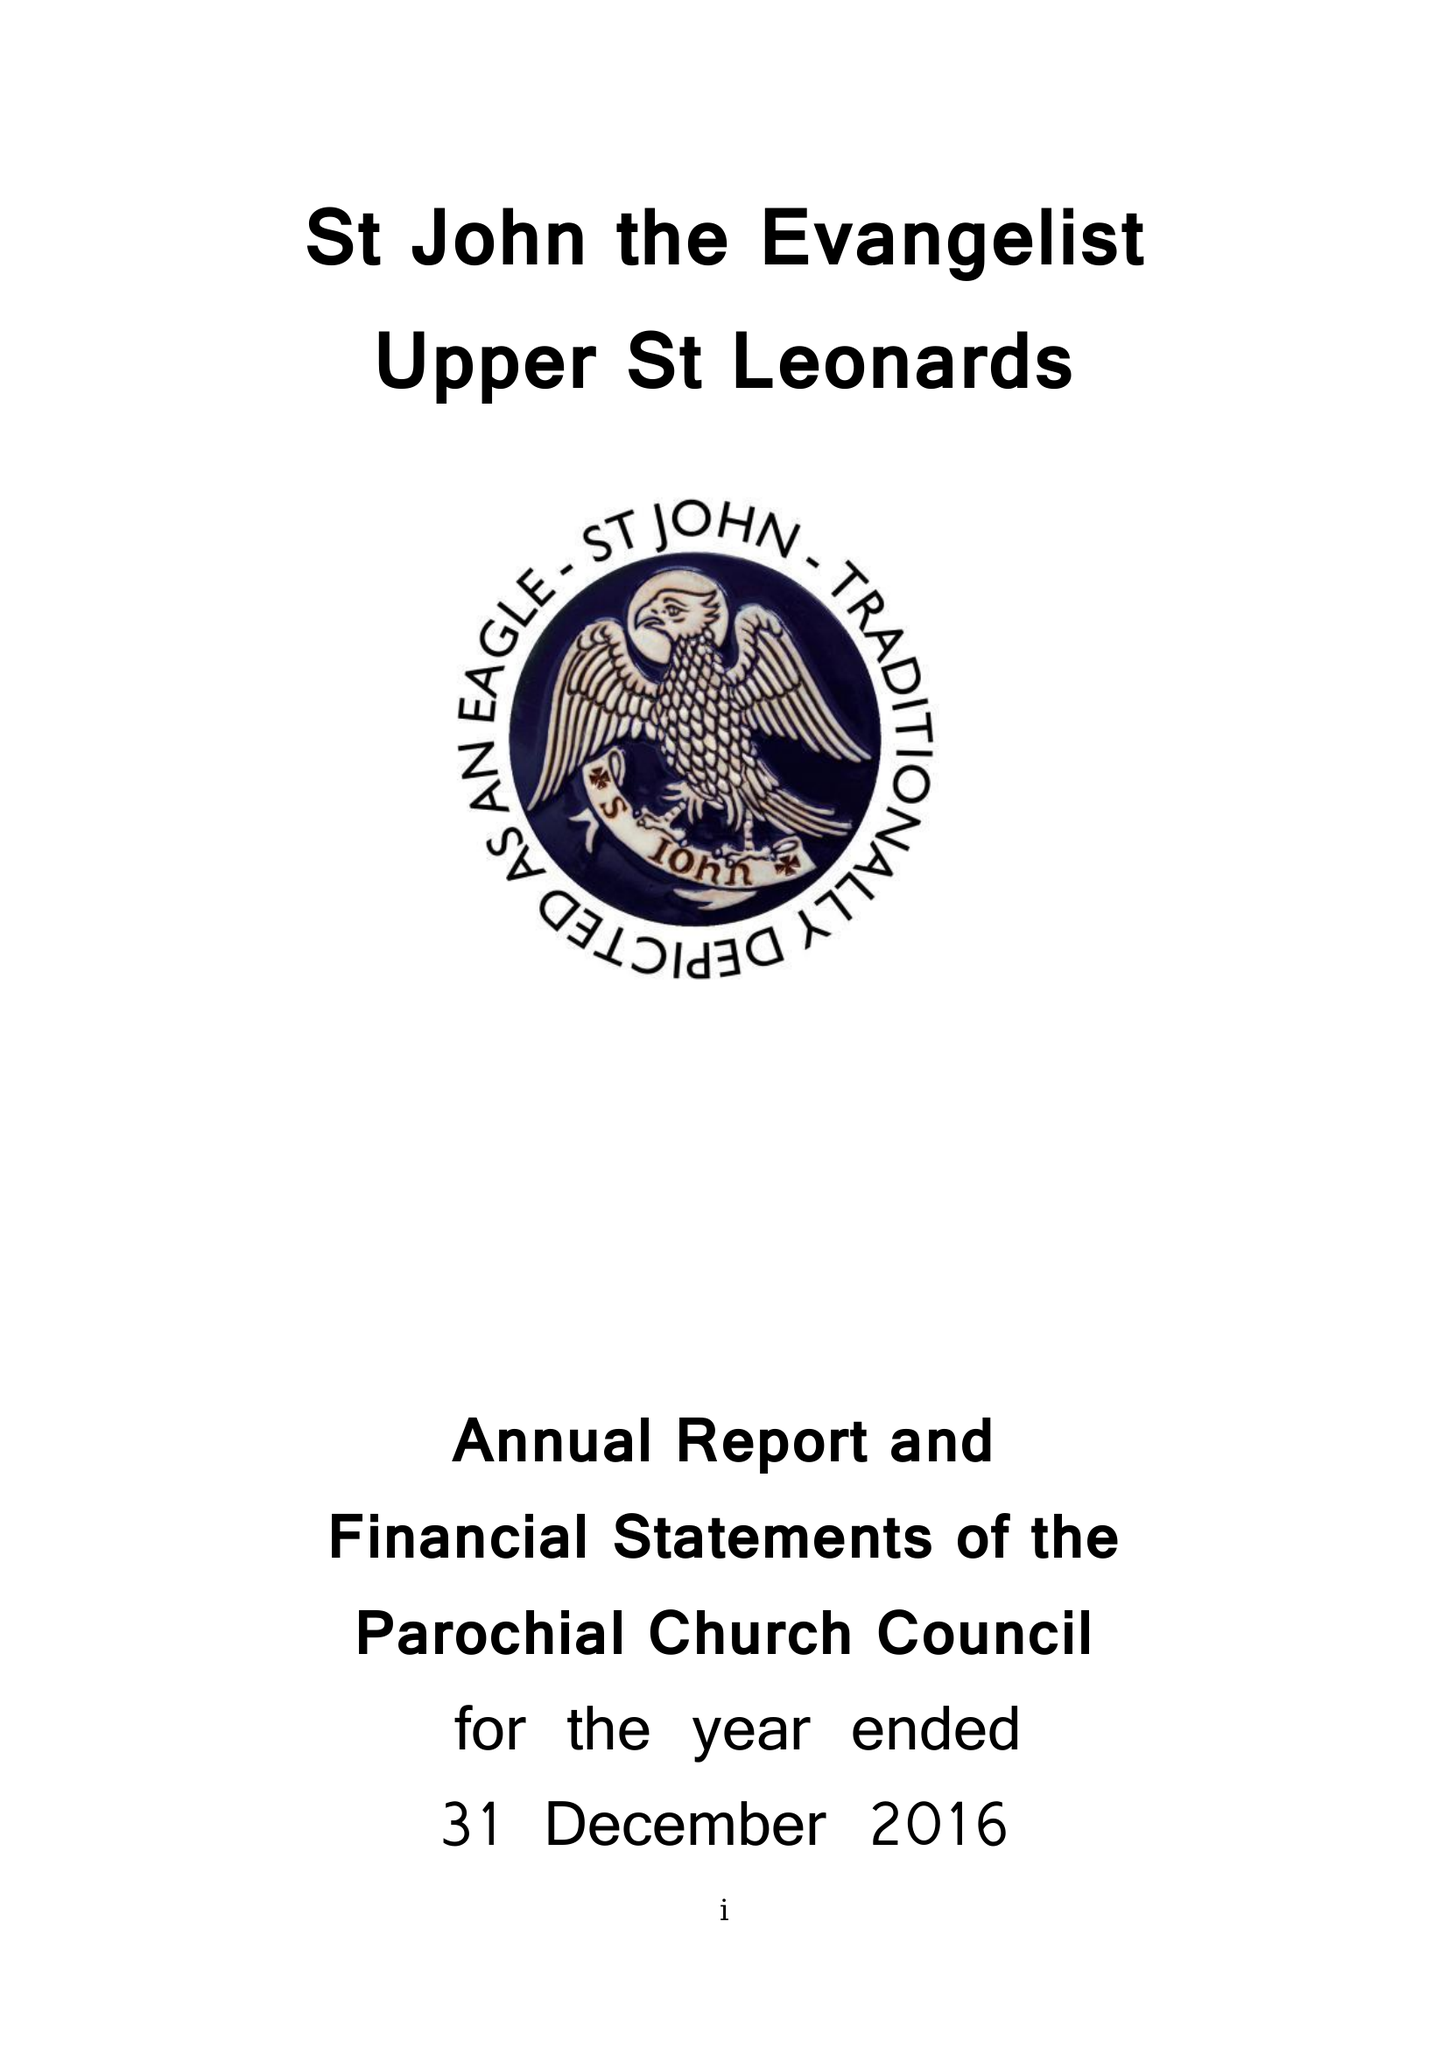What is the value for the report_date?
Answer the question using a single word or phrase. 2016-12-31 